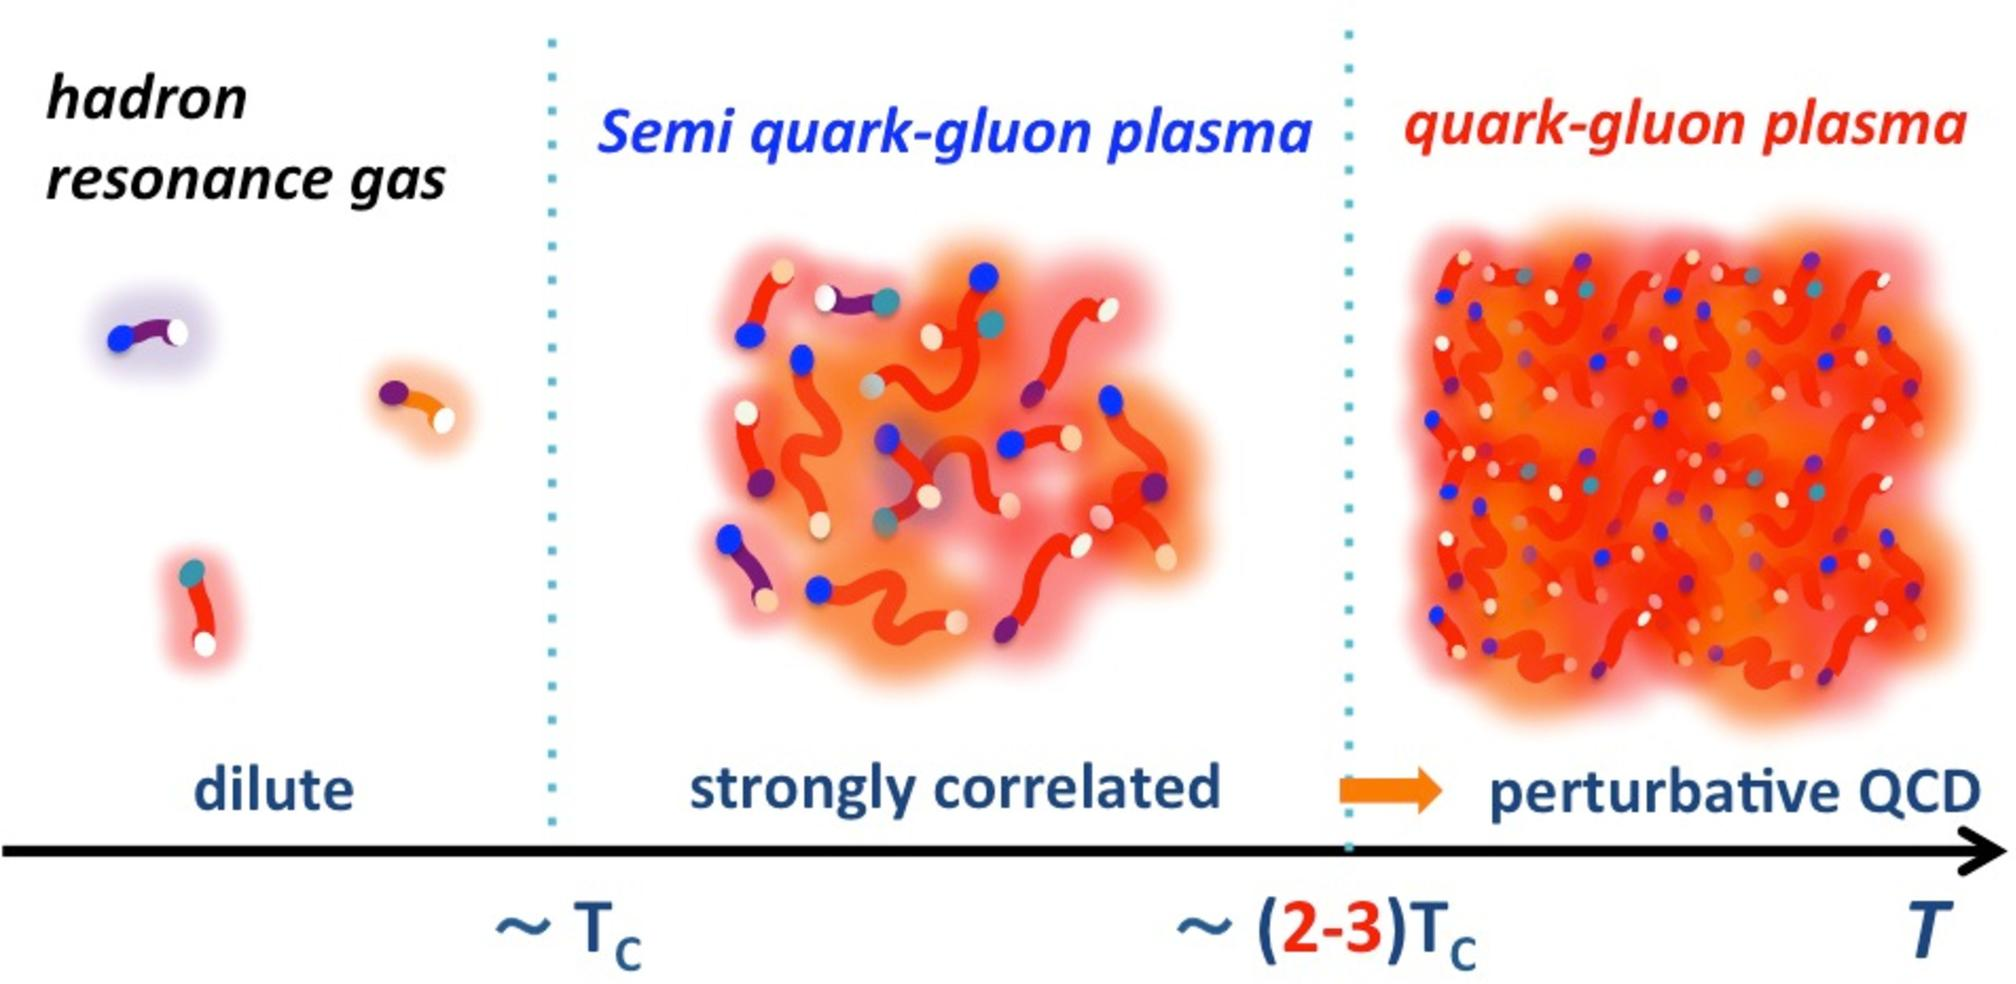Can you explain what the presence of blue and purple dots in the quark-gluon plasma signifies? The blue and purple dots in the quark-gluon plasma represent gluons and quarks, respectively. In the context of the image, the varied placement and grouping of these particles highlight the interaction strength and the degree of freedom they possess within the plasma. The closer grouping in the semi quark-gluon phase suggests stronger interactions among particles, whereas the more dispersed arrangement in the quark-gluon phase indicates that as the temperature increases, these particles have more freedom to move, symbolizing weaker inter-particle forces. 